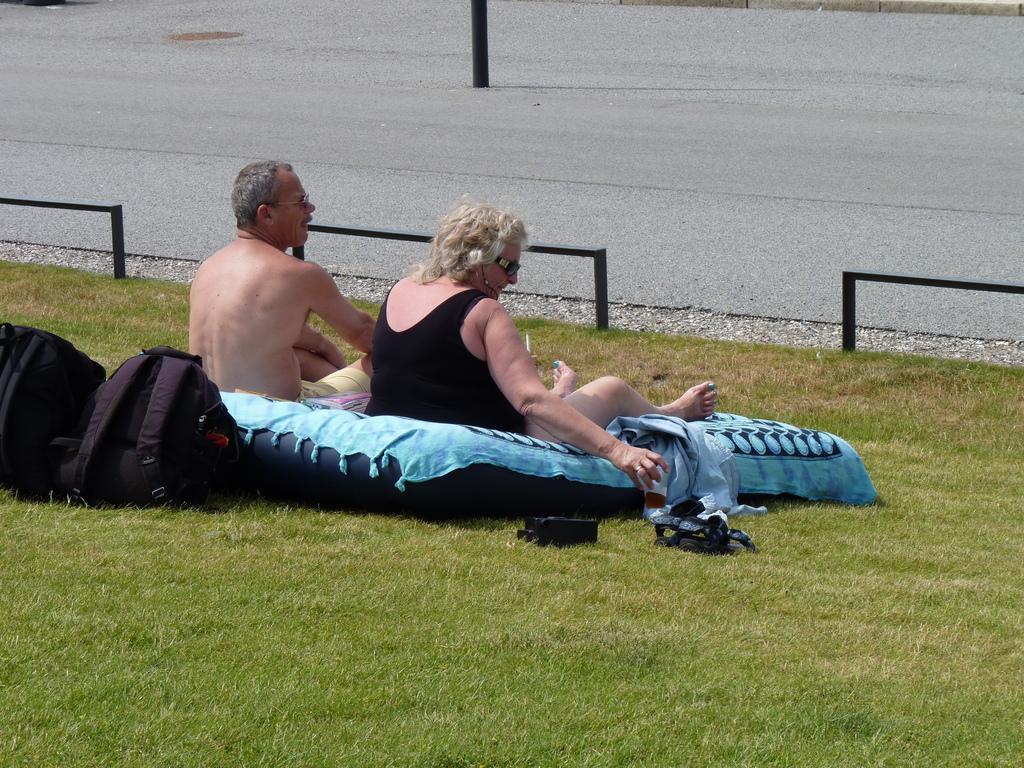Describe this image in one or two sentences. In the picture we can see a grass surface on it, we can see a man and a woman are sitting and near them, we can see a bed sheet which is blue in color and some bags near to it and a footwear and in the background we can see a path with a poll on it. 